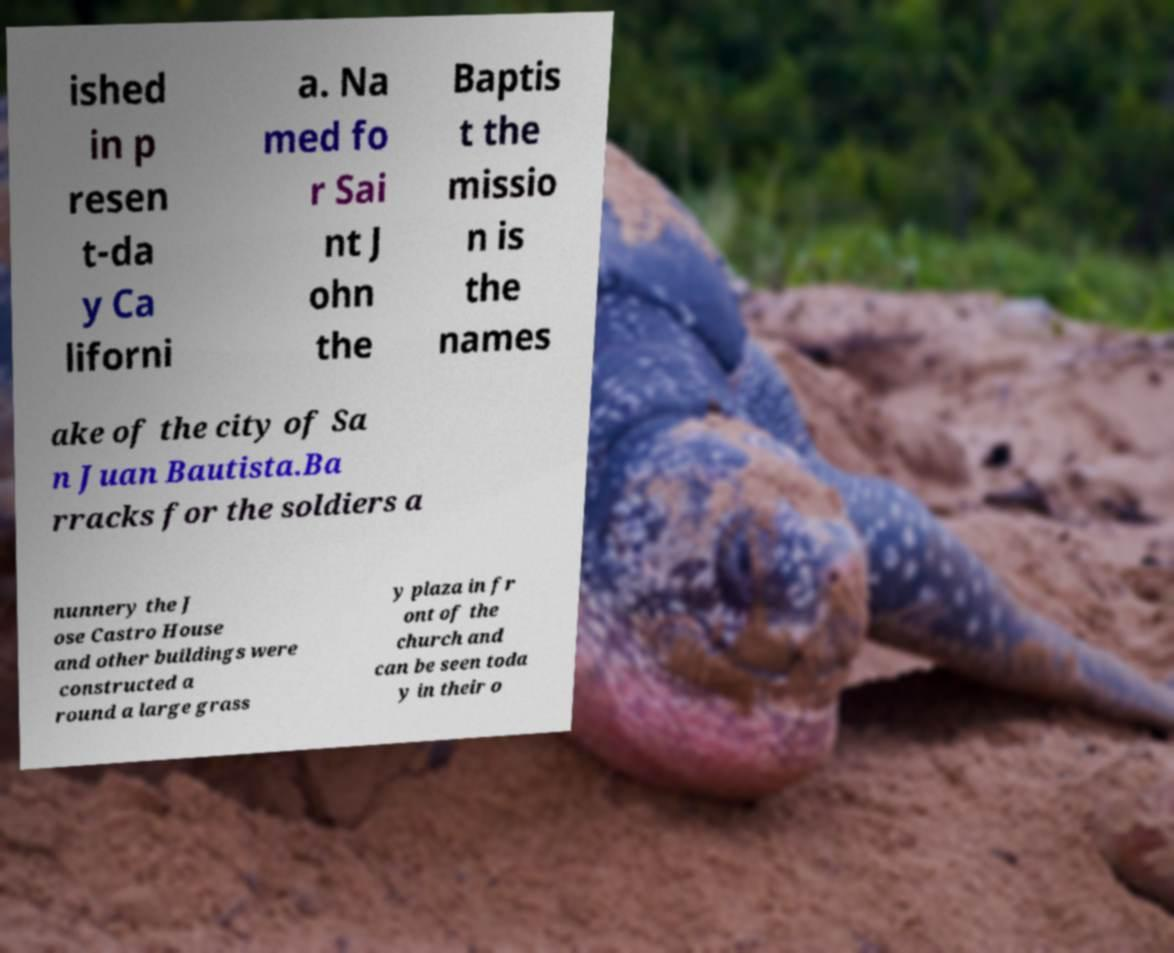Please identify and transcribe the text found in this image. ished in p resen t-da y Ca liforni a. Na med fo r Sai nt J ohn the Baptis t the missio n is the names ake of the city of Sa n Juan Bautista.Ba rracks for the soldiers a nunnery the J ose Castro House and other buildings were constructed a round a large grass y plaza in fr ont of the church and can be seen toda y in their o 